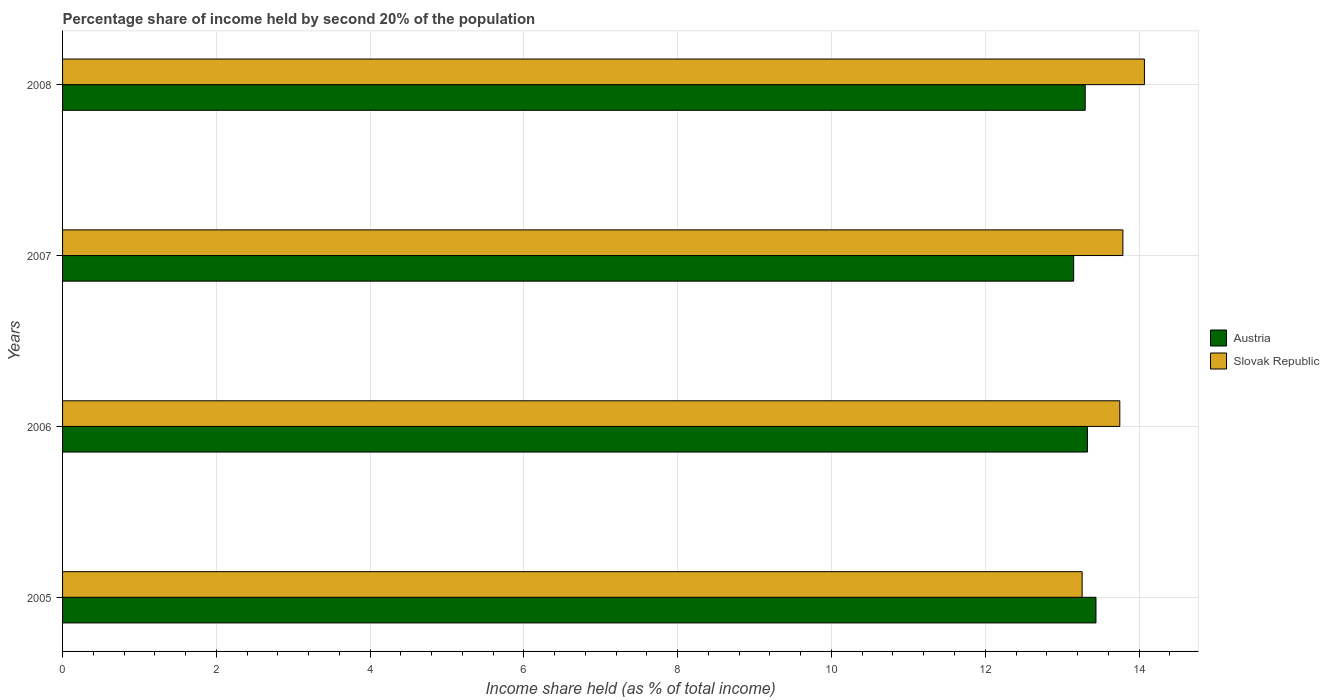How many groups of bars are there?
Your response must be concise. 4. How many bars are there on the 3rd tick from the bottom?
Your response must be concise. 2. What is the share of income held by second 20% of the population in Slovak Republic in 2008?
Your answer should be very brief. 14.07. Across all years, what is the maximum share of income held by second 20% of the population in Austria?
Your answer should be very brief. 13.44. Across all years, what is the minimum share of income held by second 20% of the population in Austria?
Make the answer very short. 13.15. What is the total share of income held by second 20% of the population in Austria in the graph?
Make the answer very short. 53.22. What is the difference between the share of income held by second 20% of the population in Austria in 2005 and that in 2007?
Provide a succinct answer. 0.29. What is the difference between the share of income held by second 20% of the population in Austria in 2006 and the share of income held by second 20% of the population in Slovak Republic in 2005?
Make the answer very short. 0.07. What is the average share of income held by second 20% of the population in Austria per year?
Provide a short and direct response. 13.3. In the year 2007, what is the difference between the share of income held by second 20% of the population in Austria and share of income held by second 20% of the population in Slovak Republic?
Keep it short and to the point. -0.64. What is the ratio of the share of income held by second 20% of the population in Slovak Republic in 2007 to that in 2008?
Ensure brevity in your answer.  0.98. Is the share of income held by second 20% of the population in Austria in 2005 less than that in 2007?
Provide a short and direct response. No. What is the difference between the highest and the second highest share of income held by second 20% of the population in Austria?
Your answer should be compact. 0.11. What is the difference between the highest and the lowest share of income held by second 20% of the population in Slovak Republic?
Your response must be concise. 0.81. In how many years, is the share of income held by second 20% of the population in Austria greater than the average share of income held by second 20% of the population in Austria taken over all years?
Offer a terse response. 2. What does the 2nd bar from the top in 2008 represents?
Make the answer very short. Austria. Does the graph contain any zero values?
Ensure brevity in your answer.  No. Does the graph contain grids?
Your answer should be compact. Yes. Where does the legend appear in the graph?
Provide a short and direct response. Center right. How many legend labels are there?
Keep it short and to the point. 2. How are the legend labels stacked?
Offer a very short reply. Vertical. What is the title of the graph?
Offer a terse response. Percentage share of income held by second 20% of the population. What is the label or title of the X-axis?
Give a very brief answer. Income share held (as % of total income). What is the label or title of the Y-axis?
Ensure brevity in your answer.  Years. What is the Income share held (as % of total income) of Austria in 2005?
Your answer should be compact. 13.44. What is the Income share held (as % of total income) of Slovak Republic in 2005?
Offer a very short reply. 13.26. What is the Income share held (as % of total income) in Austria in 2006?
Provide a succinct answer. 13.33. What is the Income share held (as % of total income) of Slovak Republic in 2006?
Make the answer very short. 13.75. What is the Income share held (as % of total income) in Austria in 2007?
Your answer should be very brief. 13.15. What is the Income share held (as % of total income) in Slovak Republic in 2007?
Offer a very short reply. 13.79. What is the Income share held (as % of total income) of Austria in 2008?
Your answer should be very brief. 13.3. What is the Income share held (as % of total income) of Slovak Republic in 2008?
Your answer should be very brief. 14.07. Across all years, what is the maximum Income share held (as % of total income) of Austria?
Your answer should be very brief. 13.44. Across all years, what is the maximum Income share held (as % of total income) of Slovak Republic?
Provide a succinct answer. 14.07. Across all years, what is the minimum Income share held (as % of total income) in Austria?
Keep it short and to the point. 13.15. Across all years, what is the minimum Income share held (as % of total income) of Slovak Republic?
Your answer should be compact. 13.26. What is the total Income share held (as % of total income) of Austria in the graph?
Provide a short and direct response. 53.22. What is the total Income share held (as % of total income) of Slovak Republic in the graph?
Your response must be concise. 54.87. What is the difference between the Income share held (as % of total income) in Austria in 2005 and that in 2006?
Your answer should be very brief. 0.11. What is the difference between the Income share held (as % of total income) of Slovak Republic in 2005 and that in 2006?
Your answer should be compact. -0.49. What is the difference between the Income share held (as % of total income) in Austria in 2005 and that in 2007?
Provide a short and direct response. 0.29. What is the difference between the Income share held (as % of total income) of Slovak Republic in 2005 and that in 2007?
Offer a very short reply. -0.53. What is the difference between the Income share held (as % of total income) in Austria in 2005 and that in 2008?
Make the answer very short. 0.14. What is the difference between the Income share held (as % of total income) in Slovak Republic in 2005 and that in 2008?
Offer a very short reply. -0.81. What is the difference between the Income share held (as % of total income) in Austria in 2006 and that in 2007?
Your answer should be very brief. 0.18. What is the difference between the Income share held (as % of total income) of Slovak Republic in 2006 and that in 2007?
Offer a terse response. -0.04. What is the difference between the Income share held (as % of total income) in Austria in 2006 and that in 2008?
Offer a very short reply. 0.03. What is the difference between the Income share held (as % of total income) of Slovak Republic in 2006 and that in 2008?
Your answer should be very brief. -0.32. What is the difference between the Income share held (as % of total income) in Slovak Republic in 2007 and that in 2008?
Your answer should be very brief. -0.28. What is the difference between the Income share held (as % of total income) of Austria in 2005 and the Income share held (as % of total income) of Slovak Republic in 2006?
Make the answer very short. -0.31. What is the difference between the Income share held (as % of total income) of Austria in 2005 and the Income share held (as % of total income) of Slovak Republic in 2007?
Provide a succinct answer. -0.35. What is the difference between the Income share held (as % of total income) in Austria in 2005 and the Income share held (as % of total income) in Slovak Republic in 2008?
Provide a short and direct response. -0.63. What is the difference between the Income share held (as % of total income) in Austria in 2006 and the Income share held (as % of total income) in Slovak Republic in 2007?
Provide a succinct answer. -0.46. What is the difference between the Income share held (as % of total income) of Austria in 2006 and the Income share held (as % of total income) of Slovak Republic in 2008?
Your answer should be compact. -0.74. What is the difference between the Income share held (as % of total income) in Austria in 2007 and the Income share held (as % of total income) in Slovak Republic in 2008?
Your response must be concise. -0.92. What is the average Income share held (as % of total income) of Austria per year?
Ensure brevity in your answer.  13.3. What is the average Income share held (as % of total income) of Slovak Republic per year?
Give a very brief answer. 13.72. In the year 2005, what is the difference between the Income share held (as % of total income) in Austria and Income share held (as % of total income) in Slovak Republic?
Offer a terse response. 0.18. In the year 2006, what is the difference between the Income share held (as % of total income) in Austria and Income share held (as % of total income) in Slovak Republic?
Provide a short and direct response. -0.42. In the year 2007, what is the difference between the Income share held (as % of total income) in Austria and Income share held (as % of total income) in Slovak Republic?
Offer a very short reply. -0.64. In the year 2008, what is the difference between the Income share held (as % of total income) of Austria and Income share held (as % of total income) of Slovak Republic?
Your answer should be compact. -0.77. What is the ratio of the Income share held (as % of total income) of Austria in 2005 to that in 2006?
Your response must be concise. 1.01. What is the ratio of the Income share held (as % of total income) of Slovak Republic in 2005 to that in 2006?
Ensure brevity in your answer.  0.96. What is the ratio of the Income share held (as % of total income) in Austria in 2005 to that in 2007?
Your response must be concise. 1.02. What is the ratio of the Income share held (as % of total income) in Slovak Republic in 2005 to that in 2007?
Give a very brief answer. 0.96. What is the ratio of the Income share held (as % of total income) of Austria in 2005 to that in 2008?
Your response must be concise. 1.01. What is the ratio of the Income share held (as % of total income) of Slovak Republic in 2005 to that in 2008?
Keep it short and to the point. 0.94. What is the ratio of the Income share held (as % of total income) in Austria in 2006 to that in 2007?
Provide a short and direct response. 1.01. What is the ratio of the Income share held (as % of total income) in Slovak Republic in 2006 to that in 2007?
Offer a terse response. 1. What is the ratio of the Income share held (as % of total income) of Slovak Republic in 2006 to that in 2008?
Offer a terse response. 0.98. What is the ratio of the Income share held (as % of total income) in Austria in 2007 to that in 2008?
Provide a short and direct response. 0.99. What is the ratio of the Income share held (as % of total income) in Slovak Republic in 2007 to that in 2008?
Your answer should be very brief. 0.98. What is the difference between the highest and the second highest Income share held (as % of total income) of Austria?
Offer a very short reply. 0.11. What is the difference between the highest and the second highest Income share held (as % of total income) of Slovak Republic?
Your answer should be very brief. 0.28. What is the difference between the highest and the lowest Income share held (as % of total income) of Austria?
Offer a very short reply. 0.29. What is the difference between the highest and the lowest Income share held (as % of total income) in Slovak Republic?
Make the answer very short. 0.81. 